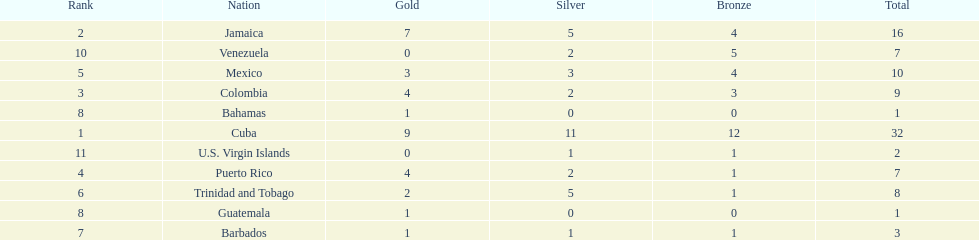Only team to have more than 30 medals Cuba. 